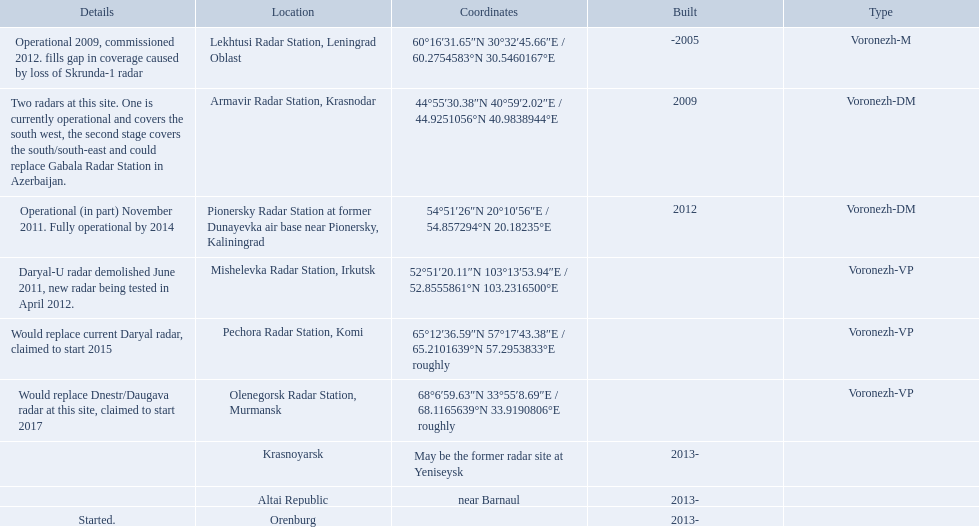Which column has the coordinates starting with 60 deg? 60°16′31.65″N 30°32′45.66″E﻿ / ﻿60.2754583°N 30.5460167°E. What is the location in the same row as that column? Lekhtusi Radar Station, Leningrad Oblast. 